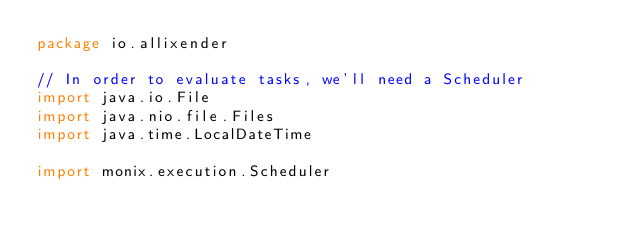<code> <loc_0><loc_0><loc_500><loc_500><_Scala_>package io.allixender

// In order to evaluate tasks, we'll need a Scheduler
import java.io.File
import java.nio.file.Files
import java.time.LocalDateTime

import monix.execution.Scheduler
</code> 